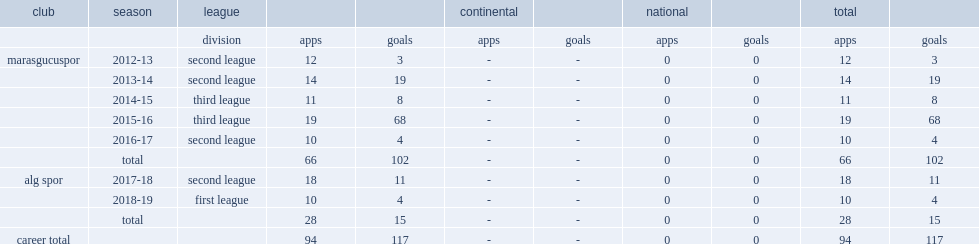Which club did mislina gozukara play for in 2017-18? Alg spor. 